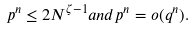Convert formula to latex. <formula><loc_0><loc_0><loc_500><loc_500>p ^ { n } \leq 2 N ^ { \zeta - 1 } a n d p ^ { n } = o ( q ^ { n } ) .</formula> 